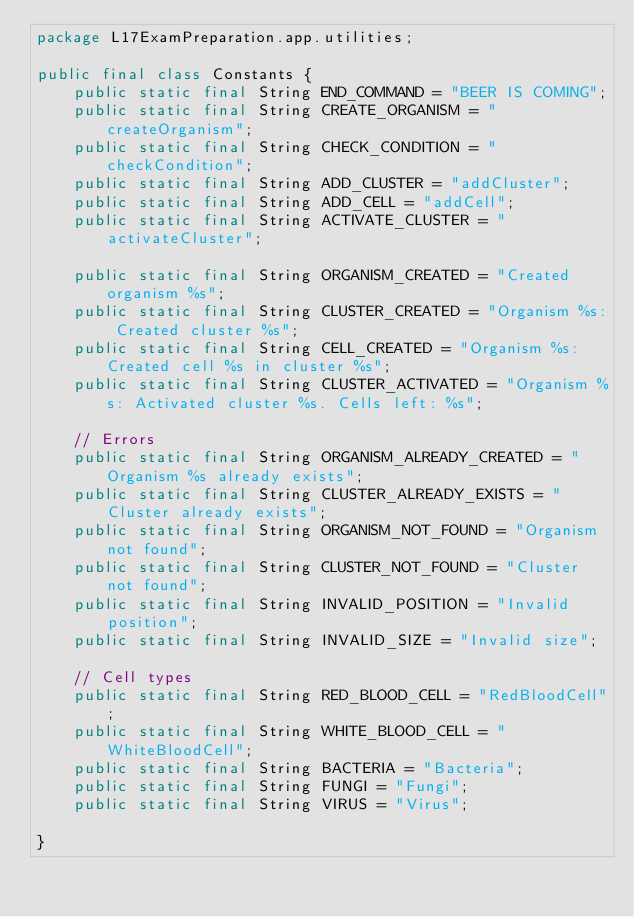Convert code to text. <code><loc_0><loc_0><loc_500><loc_500><_Java_>package L17ExamPreparation.app.utilities;

public final class Constants {
    public static final String END_COMMAND = "BEER IS COMING";
    public static final String CREATE_ORGANISM = "createOrganism";
    public static final String CHECK_CONDITION = "checkCondition";
    public static final String ADD_CLUSTER = "addCluster";
    public static final String ADD_CELL = "addCell";
    public static final String ACTIVATE_CLUSTER = "activateCluster";

    public static final String ORGANISM_CREATED = "Created organism %s";
    public static final String CLUSTER_CREATED = "Organism %s: Created cluster %s";
    public static final String CELL_CREATED = "Organism %s: Created cell %s in cluster %s";
    public static final String CLUSTER_ACTIVATED = "Organism %s: Activated cluster %s. Cells left: %s";

    // Errors
    public static final String ORGANISM_ALREADY_CREATED = "Organism %s already exists";
    public static final String CLUSTER_ALREADY_EXISTS = "Cluster already exists";
    public static final String ORGANISM_NOT_FOUND = "Organism not found";
    public static final String CLUSTER_NOT_FOUND = "Cluster not found";
    public static final String INVALID_POSITION = "Invalid position";
    public static final String INVALID_SIZE = "Invalid size";

    // Cell types
    public static final String RED_BLOOD_CELL = "RedBloodCell";
    public static final String WHITE_BLOOD_CELL = "WhiteBloodCell";
    public static final String BACTERIA = "Bacteria";
    public static final String FUNGI = "Fungi";
    public static final String VIRUS = "Virus";

}
</code> 